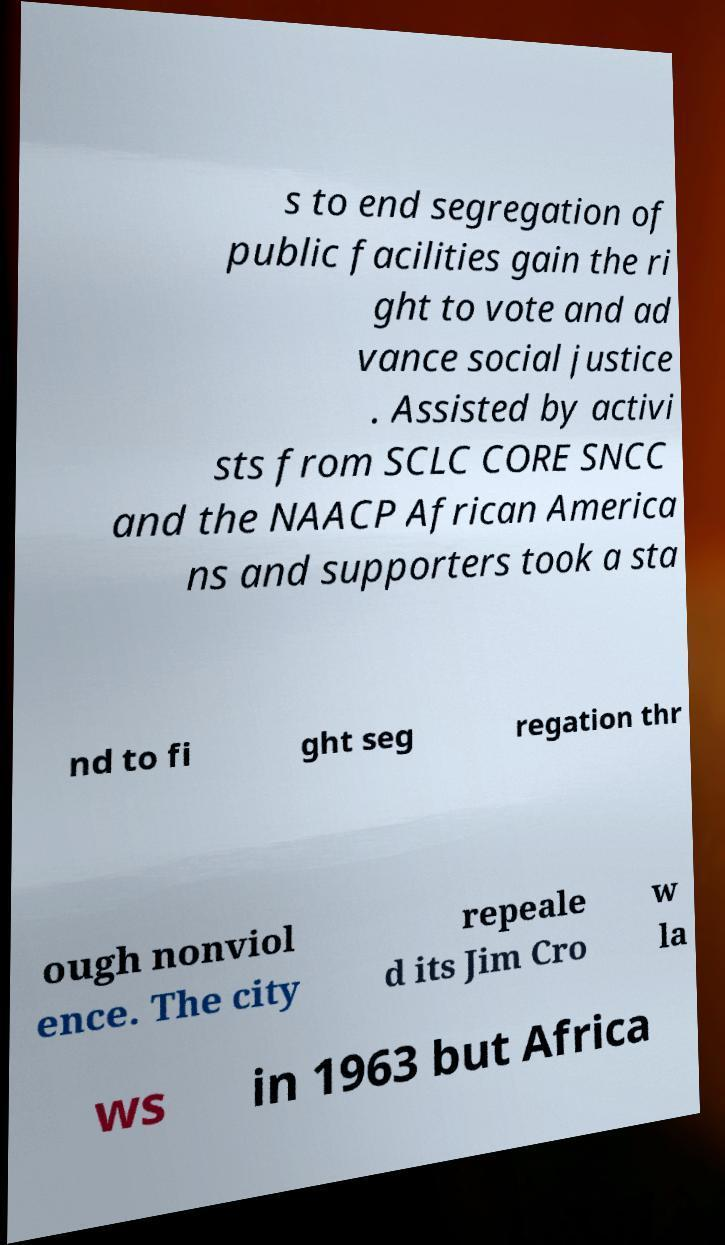There's text embedded in this image that I need extracted. Can you transcribe it verbatim? s to end segregation of public facilities gain the ri ght to vote and ad vance social justice . Assisted by activi sts from SCLC CORE SNCC and the NAACP African America ns and supporters took a sta nd to fi ght seg regation thr ough nonviol ence. The city repeale d its Jim Cro w la ws in 1963 but Africa 